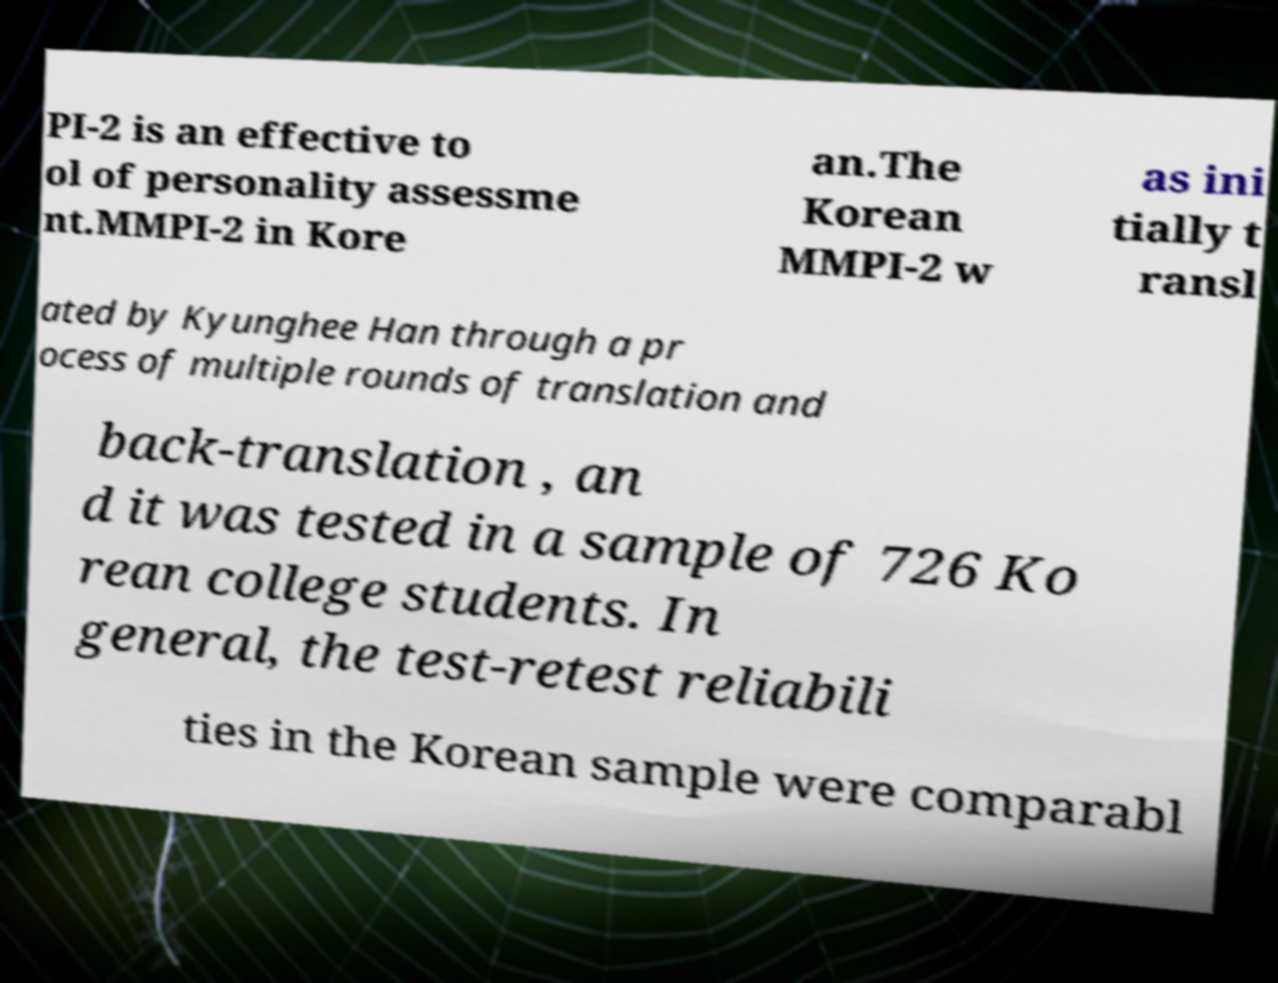Could you extract and type out the text from this image? PI-2 is an effective to ol of personality assessme nt.MMPI-2 in Kore an.The Korean MMPI-2 w as ini tially t ransl ated by Kyunghee Han through a pr ocess of multiple rounds of translation and back-translation , an d it was tested in a sample of 726 Ko rean college students. In general, the test-retest reliabili ties in the Korean sample were comparabl 